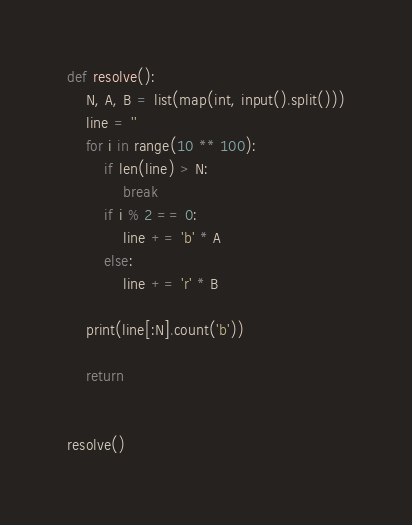<code> <loc_0><loc_0><loc_500><loc_500><_Python_>def resolve():
    N, A, B = list(map(int, input().split()))
    line = ''
    for i in range(10 ** 100):
        if len(line) > N:
            break
        if i % 2 == 0:
            line += 'b' * A
        else:
            line += 'r' * B

    print(line[:N].count('b'))

    return


resolve()</code> 